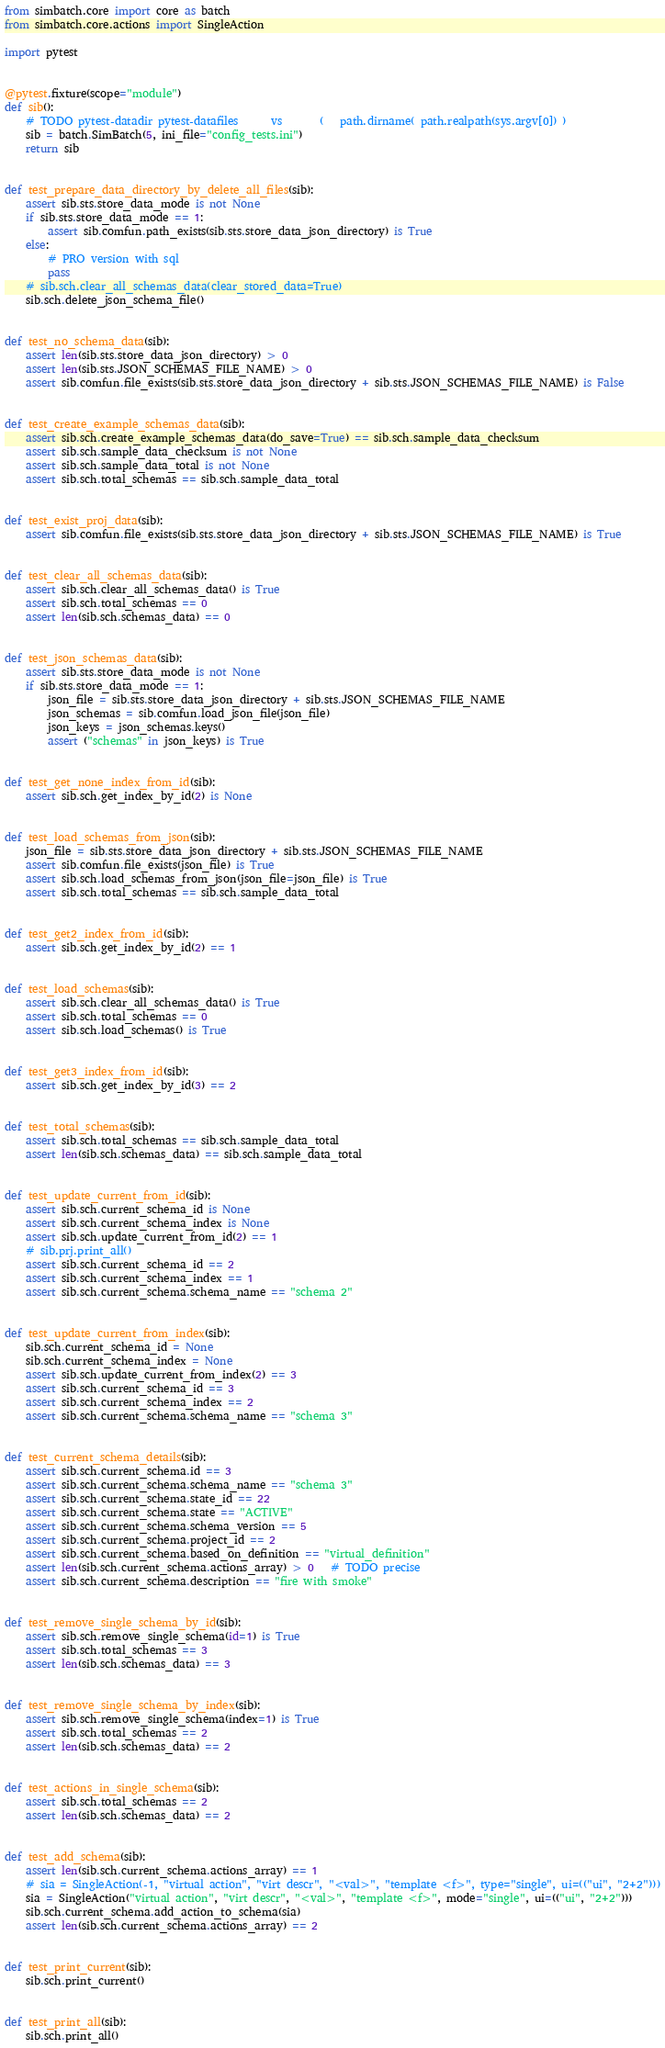<code> <loc_0><loc_0><loc_500><loc_500><_Python_>from simbatch.core import core as batch
from simbatch.core.actions import SingleAction

import pytest


@pytest.fixture(scope="module")
def sib():
    # TODO pytest-datadir pytest-datafiles      vs       (   path.dirname( path.realpath(sys.argv[0]) )
    sib = batch.SimBatch(5, ini_file="config_tests.ini")
    return sib


def test_prepare_data_directory_by_delete_all_files(sib):
    assert sib.sts.store_data_mode is not None
    if sib.sts.store_data_mode == 1:
        assert sib.comfun.path_exists(sib.sts.store_data_json_directory) is True
    else:
        # PRO version with sql
        pass
    # sib.sch.clear_all_schemas_data(clear_stored_data=True)
    sib.sch.delete_json_schema_file()


def test_no_schema_data(sib):
    assert len(sib.sts.store_data_json_directory) > 0
    assert len(sib.sts.JSON_SCHEMAS_FILE_NAME) > 0
    assert sib.comfun.file_exists(sib.sts.store_data_json_directory + sib.sts.JSON_SCHEMAS_FILE_NAME) is False


def test_create_example_schemas_data(sib):
    assert sib.sch.create_example_schemas_data(do_save=True) == sib.sch.sample_data_checksum
    assert sib.sch.sample_data_checksum is not None
    assert sib.sch.sample_data_total is not None
    assert sib.sch.total_schemas == sib.sch.sample_data_total


def test_exist_proj_data(sib):
    assert sib.comfun.file_exists(sib.sts.store_data_json_directory + sib.sts.JSON_SCHEMAS_FILE_NAME) is True


def test_clear_all_schemas_data(sib):
    assert sib.sch.clear_all_schemas_data() is True
    assert sib.sch.total_schemas == 0
    assert len(sib.sch.schemas_data) == 0


def test_json_schemas_data(sib):
    assert sib.sts.store_data_mode is not None
    if sib.sts.store_data_mode == 1:
        json_file = sib.sts.store_data_json_directory + sib.sts.JSON_SCHEMAS_FILE_NAME
        json_schemas = sib.comfun.load_json_file(json_file)
        json_keys = json_schemas.keys()
        assert ("schemas" in json_keys) is True


def test_get_none_index_from_id(sib):
    assert sib.sch.get_index_by_id(2) is None


def test_load_schemas_from_json(sib):
    json_file = sib.sts.store_data_json_directory + sib.sts.JSON_SCHEMAS_FILE_NAME
    assert sib.comfun.file_exists(json_file) is True
    assert sib.sch.load_schemas_from_json(json_file=json_file) is True
    assert sib.sch.total_schemas == sib.sch.sample_data_total


def test_get2_index_from_id(sib):
    assert sib.sch.get_index_by_id(2) == 1


def test_load_schemas(sib):
    assert sib.sch.clear_all_schemas_data() is True
    assert sib.sch.total_schemas == 0
    assert sib.sch.load_schemas() is True


def test_get3_index_from_id(sib):
    assert sib.sch.get_index_by_id(3) == 2


def test_total_schemas(sib):
    assert sib.sch.total_schemas == sib.sch.sample_data_total
    assert len(sib.sch.schemas_data) == sib.sch.sample_data_total


def test_update_current_from_id(sib):
    assert sib.sch.current_schema_id is None
    assert sib.sch.current_schema_index is None
    assert sib.sch.update_current_from_id(2) == 1
    # sib.prj.print_all()
    assert sib.sch.current_schema_id == 2
    assert sib.sch.current_schema_index == 1
    assert sib.sch.current_schema.schema_name == "schema 2"


def test_update_current_from_index(sib):
    sib.sch.current_schema_id = None
    sib.sch.current_schema_index = None
    assert sib.sch.update_current_from_index(2) == 3
    assert sib.sch.current_schema_id == 3
    assert sib.sch.current_schema_index == 2
    assert sib.sch.current_schema.schema_name == "schema 3"


def test_current_schema_details(sib):
    assert sib.sch.current_schema.id == 3
    assert sib.sch.current_schema.schema_name == "schema 3"
    assert sib.sch.current_schema.state_id == 22
    assert sib.sch.current_schema.state == "ACTIVE"
    assert sib.sch.current_schema.schema_version == 5
    assert sib.sch.current_schema.project_id == 2
    assert sib.sch.current_schema.based_on_definition == "virtual_definition"
    assert len(sib.sch.current_schema.actions_array) > 0   # TODO precise
    assert sib.sch.current_schema.description == "fire with smoke"


def test_remove_single_schema_by_id(sib):
    assert sib.sch.remove_single_schema(id=1) is True
    assert sib.sch.total_schemas == 3
    assert len(sib.sch.schemas_data) == 3


def test_remove_single_schema_by_index(sib):
    assert sib.sch.remove_single_schema(index=1) is True
    assert sib.sch.total_schemas == 2
    assert len(sib.sch.schemas_data) == 2


def test_actions_in_single_schema(sib):
    assert sib.sch.total_schemas == 2
    assert len(sib.sch.schemas_data) == 2


def test_add_schema(sib):
    assert len(sib.sch.current_schema.actions_array) == 1
    # sia = SingleAction(-1, "virtual action", "virt descr", "<val>", "template <f>", type="single", ui=(("ui", "2+2")))
    sia = SingleAction("virtual action", "virt descr", "<val>", "template <f>", mode="single", ui=(("ui", "2+2")))
    sib.sch.current_schema.add_action_to_schema(sia)
    assert len(sib.sch.current_schema.actions_array) == 2


def test_print_current(sib):
    sib.sch.print_current()


def test_print_all(sib):
    sib.sch.print_all()
</code> 